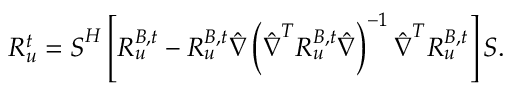Convert formula to latex. <formula><loc_0><loc_0><loc_500><loc_500>R _ { u } ^ { t } = S ^ { H } \left [ R _ { u } ^ { B , t } - R _ { u } ^ { B , t } \hat { \nabla } \left ( \hat { \nabla } ^ { T } R _ { u } ^ { B , t } \hat { \nabla } \right ) ^ { - 1 } \hat { \nabla } ^ { T } R _ { u } ^ { B , t } \right ] S .</formula> 